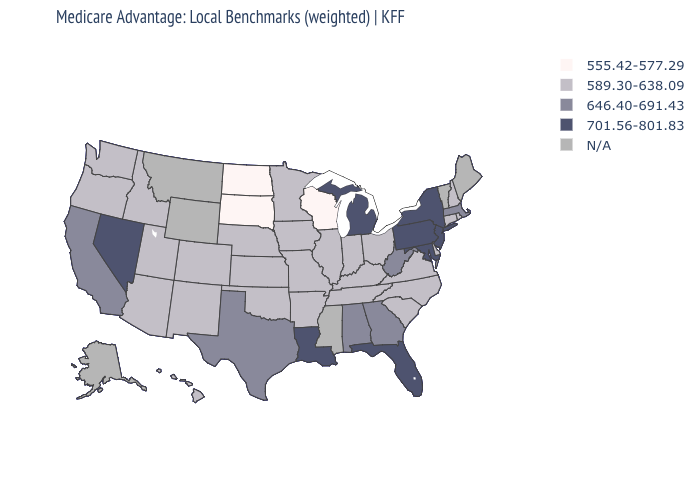What is the highest value in the USA?
Short answer required. 701.56-801.83. Which states have the lowest value in the MidWest?
Keep it brief. North Dakota, South Dakota, Wisconsin. Among the states that border Louisiana , which have the highest value?
Be succinct. Texas. Name the states that have a value in the range 555.42-577.29?
Short answer required. North Dakota, South Dakota, Wisconsin. What is the highest value in the USA?
Write a very short answer. 701.56-801.83. What is the value of Delaware?
Short answer required. 589.30-638.09. What is the lowest value in the West?
Be succinct. 589.30-638.09. What is the value of Maine?
Short answer required. N/A. What is the lowest value in states that border Massachusetts?
Keep it brief. 589.30-638.09. How many symbols are there in the legend?
Keep it brief. 5. What is the highest value in the USA?
Keep it brief. 701.56-801.83. What is the highest value in states that border Georgia?
Write a very short answer. 701.56-801.83. Which states have the lowest value in the West?
Write a very short answer. Arizona, Colorado, Hawaii, Idaho, New Mexico, Oregon, Utah, Washington. 